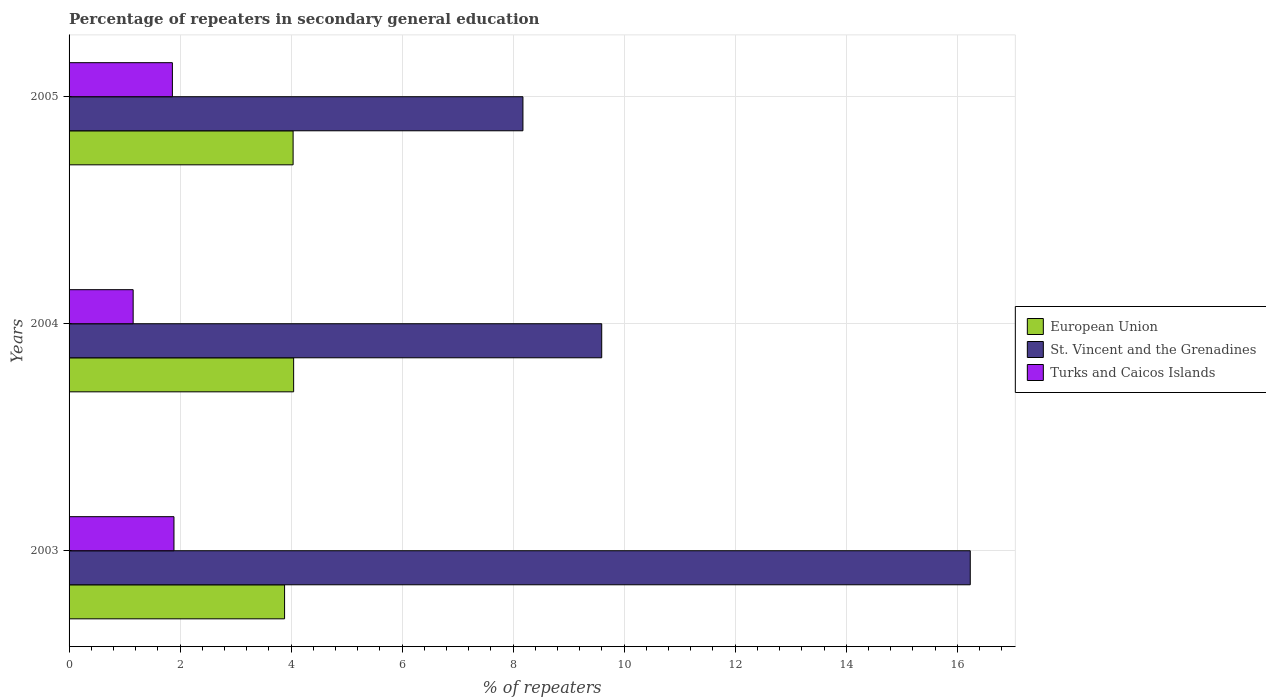How many different coloured bars are there?
Your answer should be compact. 3. How many groups of bars are there?
Offer a very short reply. 3. Are the number of bars per tick equal to the number of legend labels?
Provide a short and direct response. Yes. Are the number of bars on each tick of the Y-axis equal?
Your response must be concise. Yes. How many bars are there on the 3rd tick from the top?
Your response must be concise. 3. What is the label of the 1st group of bars from the top?
Make the answer very short. 2005. In how many cases, is the number of bars for a given year not equal to the number of legend labels?
Offer a very short reply. 0. What is the percentage of repeaters in secondary general education in St. Vincent and the Grenadines in 2005?
Offer a terse response. 8.18. Across all years, what is the maximum percentage of repeaters in secondary general education in St. Vincent and the Grenadines?
Offer a terse response. 16.23. Across all years, what is the minimum percentage of repeaters in secondary general education in European Union?
Offer a very short reply. 3.88. In which year was the percentage of repeaters in secondary general education in Turks and Caicos Islands minimum?
Provide a short and direct response. 2004. What is the total percentage of repeaters in secondary general education in Turks and Caicos Islands in the graph?
Your response must be concise. 4.91. What is the difference between the percentage of repeaters in secondary general education in European Union in 2003 and that in 2005?
Provide a succinct answer. -0.15. What is the difference between the percentage of repeaters in secondary general education in St. Vincent and the Grenadines in 2004 and the percentage of repeaters in secondary general education in Turks and Caicos Islands in 2003?
Offer a very short reply. 7.71. What is the average percentage of repeaters in secondary general education in St. Vincent and the Grenadines per year?
Offer a terse response. 11.34. In the year 2005, what is the difference between the percentage of repeaters in secondary general education in European Union and percentage of repeaters in secondary general education in St. Vincent and the Grenadines?
Your answer should be compact. -4.14. What is the ratio of the percentage of repeaters in secondary general education in Turks and Caicos Islands in 2003 to that in 2004?
Offer a very short reply. 1.64. Is the percentage of repeaters in secondary general education in St. Vincent and the Grenadines in 2003 less than that in 2004?
Give a very brief answer. No. Is the difference between the percentage of repeaters in secondary general education in European Union in 2003 and 2004 greater than the difference between the percentage of repeaters in secondary general education in St. Vincent and the Grenadines in 2003 and 2004?
Offer a terse response. No. What is the difference between the highest and the second highest percentage of repeaters in secondary general education in Turks and Caicos Islands?
Make the answer very short. 0.03. What is the difference between the highest and the lowest percentage of repeaters in secondary general education in St. Vincent and the Grenadines?
Offer a very short reply. 8.06. What does the 1st bar from the top in 2005 represents?
Provide a short and direct response. Turks and Caicos Islands. What does the 1st bar from the bottom in 2004 represents?
Provide a short and direct response. European Union. How many years are there in the graph?
Offer a very short reply. 3. Are the values on the major ticks of X-axis written in scientific E-notation?
Offer a very short reply. No. Does the graph contain any zero values?
Your answer should be very brief. No. How many legend labels are there?
Ensure brevity in your answer.  3. How are the legend labels stacked?
Offer a very short reply. Vertical. What is the title of the graph?
Keep it short and to the point. Percentage of repeaters in secondary general education. Does "Philippines" appear as one of the legend labels in the graph?
Ensure brevity in your answer.  No. What is the label or title of the X-axis?
Make the answer very short. % of repeaters. What is the % of repeaters in European Union in 2003?
Offer a very short reply. 3.88. What is the % of repeaters in St. Vincent and the Grenadines in 2003?
Give a very brief answer. 16.23. What is the % of repeaters in Turks and Caicos Islands in 2003?
Your response must be concise. 1.89. What is the % of repeaters of European Union in 2004?
Provide a short and direct response. 4.05. What is the % of repeaters of St. Vincent and the Grenadines in 2004?
Offer a very short reply. 9.6. What is the % of repeaters in Turks and Caicos Islands in 2004?
Provide a short and direct response. 1.15. What is the % of repeaters of European Union in 2005?
Provide a short and direct response. 4.04. What is the % of repeaters in St. Vincent and the Grenadines in 2005?
Offer a very short reply. 8.18. What is the % of repeaters in Turks and Caicos Islands in 2005?
Give a very brief answer. 1.86. Across all years, what is the maximum % of repeaters in European Union?
Provide a short and direct response. 4.05. Across all years, what is the maximum % of repeaters of St. Vincent and the Grenadines?
Make the answer very short. 16.23. Across all years, what is the maximum % of repeaters of Turks and Caicos Islands?
Offer a terse response. 1.89. Across all years, what is the minimum % of repeaters in European Union?
Your answer should be compact. 3.88. Across all years, what is the minimum % of repeaters of St. Vincent and the Grenadines?
Offer a very short reply. 8.18. Across all years, what is the minimum % of repeaters in Turks and Caicos Islands?
Your response must be concise. 1.15. What is the total % of repeaters of European Union in the graph?
Make the answer very short. 11.96. What is the total % of repeaters in St. Vincent and the Grenadines in the graph?
Keep it short and to the point. 34.01. What is the total % of repeaters of Turks and Caicos Islands in the graph?
Your answer should be very brief. 4.91. What is the difference between the % of repeaters of European Union in 2003 and that in 2004?
Your answer should be compact. -0.16. What is the difference between the % of repeaters in St. Vincent and the Grenadines in 2003 and that in 2004?
Keep it short and to the point. 6.64. What is the difference between the % of repeaters of Turks and Caicos Islands in 2003 and that in 2004?
Your answer should be compact. 0.74. What is the difference between the % of repeaters in European Union in 2003 and that in 2005?
Ensure brevity in your answer.  -0.15. What is the difference between the % of repeaters in St. Vincent and the Grenadines in 2003 and that in 2005?
Make the answer very short. 8.06. What is the difference between the % of repeaters in Turks and Caicos Islands in 2003 and that in 2005?
Ensure brevity in your answer.  0.03. What is the difference between the % of repeaters of European Union in 2004 and that in 2005?
Provide a short and direct response. 0.01. What is the difference between the % of repeaters of St. Vincent and the Grenadines in 2004 and that in 2005?
Give a very brief answer. 1.42. What is the difference between the % of repeaters of Turks and Caicos Islands in 2004 and that in 2005?
Provide a short and direct response. -0.71. What is the difference between the % of repeaters of European Union in 2003 and the % of repeaters of St. Vincent and the Grenadines in 2004?
Keep it short and to the point. -5.71. What is the difference between the % of repeaters in European Union in 2003 and the % of repeaters in Turks and Caicos Islands in 2004?
Make the answer very short. 2.73. What is the difference between the % of repeaters in St. Vincent and the Grenadines in 2003 and the % of repeaters in Turks and Caicos Islands in 2004?
Make the answer very short. 15.08. What is the difference between the % of repeaters in European Union in 2003 and the % of repeaters in St. Vincent and the Grenadines in 2005?
Provide a succinct answer. -4.29. What is the difference between the % of repeaters in European Union in 2003 and the % of repeaters in Turks and Caicos Islands in 2005?
Provide a short and direct response. 2.02. What is the difference between the % of repeaters in St. Vincent and the Grenadines in 2003 and the % of repeaters in Turks and Caicos Islands in 2005?
Keep it short and to the point. 14.37. What is the difference between the % of repeaters of European Union in 2004 and the % of repeaters of St. Vincent and the Grenadines in 2005?
Provide a short and direct response. -4.13. What is the difference between the % of repeaters in European Union in 2004 and the % of repeaters in Turks and Caicos Islands in 2005?
Your response must be concise. 2.18. What is the difference between the % of repeaters of St. Vincent and the Grenadines in 2004 and the % of repeaters of Turks and Caicos Islands in 2005?
Your response must be concise. 7.73. What is the average % of repeaters of European Union per year?
Your answer should be compact. 3.99. What is the average % of repeaters in St. Vincent and the Grenadines per year?
Provide a succinct answer. 11.34. What is the average % of repeaters of Turks and Caicos Islands per year?
Your response must be concise. 1.64. In the year 2003, what is the difference between the % of repeaters in European Union and % of repeaters in St. Vincent and the Grenadines?
Give a very brief answer. -12.35. In the year 2003, what is the difference between the % of repeaters in European Union and % of repeaters in Turks and Caicos Islands?
Your response must be concise. 1.99. In the year 2003, what is the difference between the % of repeaters of St. Vincent and the Grenadines and % of repeaters of Turks and Caicos Islands?
Provide a succinct answer. 14.34. In the year 2004, what is the difference between the % of repeaters of European Union and % of repeaters of St. Vincent and the Grenadines?
Provide a succinct answer. -5.55. In the year 2004, what is the difference between the % of repeaters in European Union and % of repeaters in Turks and Caicos Islands?
Offer a very short reply. 2.89. In the year 2004, what is the difference between the % of repeaters in St. Vincent and the Grenadines and % of repeaters in Turks and Caicos Islands?
Offer a very short reply. 8.44. In the year 2005, what is the difference between the % of repeaters in European Union and % of repeaters in St. Vincent and the Grenadines?
Ensure brevity in your answer.  -4.14. In the year 2005, what is the difference between the % of repeaters in European Union and % of repeaters in Turks and Caicos Islands?
Provide a short and direct response. 2.17. In the year 2005, what is the difference between the % of repeaters of St. Vincent and the Grenadines and % of repeaters of Turks and Caicos Islands?
Provide a short and direct response. 6.31. What is the ratio of the % of repeaters of European Union in 2003 to that in 2004?
Keep it short and to the point. 0.96. What is the ratio of the % of repeaters in St. Vincent and the Grenadines in 2003 to that in 2004?
Offer a terse response. 1.69. What is the ratio of the % of repeaters in Turks and Caicos Islands in 2003 to that in 2004?
Ensure brevity in your answer.  1.64. What is the ratio of the % of repeaters of European Union in 2003 to that in 2005?
Make the answer very short. 0.96. What is the ratio of the % of repeaters in St. Vincent and the Grenadines in 2003 to that in 2005?
Your answer should be compact. 1.99. What is the ratio of the % of repeaters of Turks and Caicos Islands in 2003 to that in 2005?
Ensure brevity in your answer.  1.02. What is the ratio of the % of repeaters in European Union in 2004 to that in 2005?
Your response must be concise. 1. What is the ratio of the % of repeaters in St. Vincent and the Grenadines in 2004 to that in 2005?
Your answer should be compact. 1.17. What is the ratio of the % of repeaters of Turks and Caicos Islands in 2004 to that in 2005?
Offer a very short reply. 0.62. What is the difference between the highest and the second highest % of repeaters of European Union?
Offer a very short reply. 0.01. What is the difference between the highest and the second highest % of repeaters in St. Vincent and the Grenadines?
Give a very brief answer. 6.64. What is the difference between the highest and the second highest % of repeaters of Turks and Caicos Islands?
Offer a terse response. 0.03. What is the difference between the highest and the lowest % of repeaters of European Union?
Your answer should be compact. 0.16. What is the difference between the highest and the lowest % of repeaters of St. Vincent and the Grenadines?
Provide a short and direct response. 8.06. What is the difference between the highest and the lowest % of repeaters of Turks and Caicos Islands?
Your answer should be very brief. 0.74. 